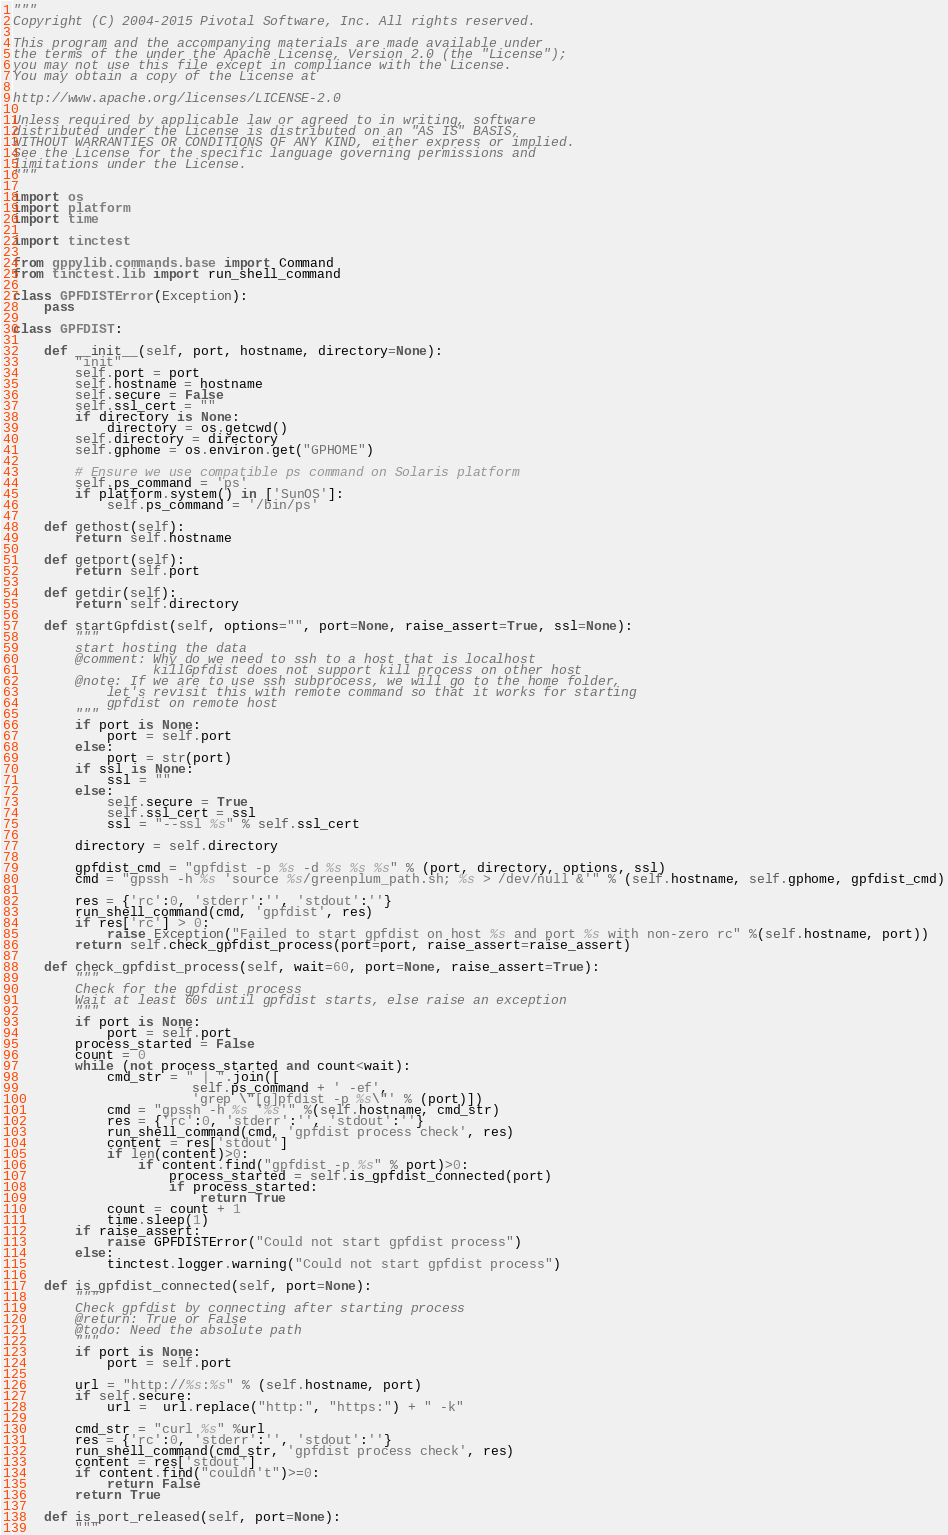Convert code to text. <code><loc_0><loc_0><loc_500><loc_500><_Python_>"""
Copyright (C) 2004-2015 Pivotal Software, Inc. All rights reserved.

This program and the accompanying materials are made available under
the terms of the under the Apache License, Version 2.0 (the "License");
you may not use this file except in compliance with the License.
You may obtain a copy of the License at

http://www.apache.org/licenses/LICENSE-2.0

Unless required by applicable law or agreed to in writing, software
distributed under the License is distributed on an "AS IS" BASIS,
WITHOUT WARRANTIES OR CONDITIONS OF ANY KIND, either express or implied.
See the License for the specific language governing permissions and
limitations under the License.
"""

import os
import platform
import time

import tinctest

from gppylib.commands.base import Command
from tinctest.lib import run_shell_command

class GPFDISTError(Exception):
    pass

class GPFDIST:

    def __init__(self, port, hostname, directory=None):
        "init"
        self.port = port
        self.hostname = hostname
        self.secure = False
        self.ssl_cert = ""
        if directory is None:
            directory = os.getcwd()
        self.directory = directory
        self.gphome = os.environ.get("GPHOME")

        # Ensure we use compatible ps command on Solaris platform
        self.ps_command = 'ps'
        if platform.system() in ['SunOS']:
            self.ps_command = '/bin/ps'

    def gethost(self):
        return self.hostname

    def getport(self):
        return self.port

    def getdir(self):
        return self.directory

    def startGpfdist(self, options="", port=None, raise_assert=True, ssl=None):
        """
        start hosting the data
        @comment: Why do we need to ssh to a host that is localhost
                  killGpfdist does not support kill process on other host
        @note: If we are to use ssh subprocess, we will go to the home folder,
            let's revisit this with remote command so that it works for starting 
            gpfdist on remote host
        """
        if port is None:
            port = self.port
        else:
            port = str(port)
        if ssl is None:
            ssl = ""
        else:
            self.secure = True
            self.ssl_cert = ssl
            ssl = "--ssl %s" % self.ssl_cert

        directory = self.directory

        gpfdist_cmd = "gpfdist -p %s -d %s %s %s" % (port, directory, options, ssl)
        cmd = "gpssh -h %s 'source %s/greenplum_path.sh; %s > /dev/null &'" % (self.hostname, self.gphome, gpfdist_cmd)
        
        res = {'rc':0, 'stderr':'', 'stdout':''}
        run_shell_command(cmd, 'gpfdist', res)
        if res['rc'] > 0:
            raise Exception("Failed to start gpfdist on host %s and port %s with non-zero rc" %(self.hostname, port))
        return self.check_gpfdist_process(port=port, raise_assert=raise_assert)

    def check_gpfdist_process(self, wait=60, port=None, raise_assert=True):
        """
        Check for the gpfdist process
        Wait at least 60s until gpfdist starts, else raise an exception
        """
        if port is None:
            port = self.port
        process_started = False
        count = 0
        while (not process_started and count<wait):
            cmd_str = " | ".join([
                       self.ps_command + ' -ef',
                       'grep \"[g]pfdist -p %s\"' % (port)])
            cmd = "gpssh -h %s '%s'" %(self.hostname, cmd_str)
            res = {'rc':0, 'stderr':'', 'stdout':''}
            run_shell_command(cmd, 'gpfdist process check', res)
            content = res['stdout']
            if len(content)>0:
                if content.find("gpfdist -p %s" % port)>0:
                    process_started = self.is_gpfdist_connected(port)
                    if process_started:
                        return True
            count = count + 1
            time.sleep(1)
        if raise_assert:
            raise GPFDISTError("Could not start gpfdist process")
        else:
            tinctest.logger.warning("Could not start gpfdist process")

    def is_gpfdist_connected(self, port=None):
        """
        Check gpfdist by connecting after starting process
        @return: True or False
        @todo: Need the absolute path
        """
        if port is None:
            port = self.port

        url = "http://%s:%s" % (self.hostname, port)
        if self.secure:
            url =  url.replace("http:", "https:") + " -k"

        cmd_str = "curl %s" %url
        res = {'rc':0, 'stderr':'', 'stdout':''}
        run_shell_command(cmd_str, 'gpfdist process check', res)
        content = res['stdout']
        if content.find("couldn't")>=0:
            return False
        return True

    def is_port_released(self, port=None):
        """</code> 